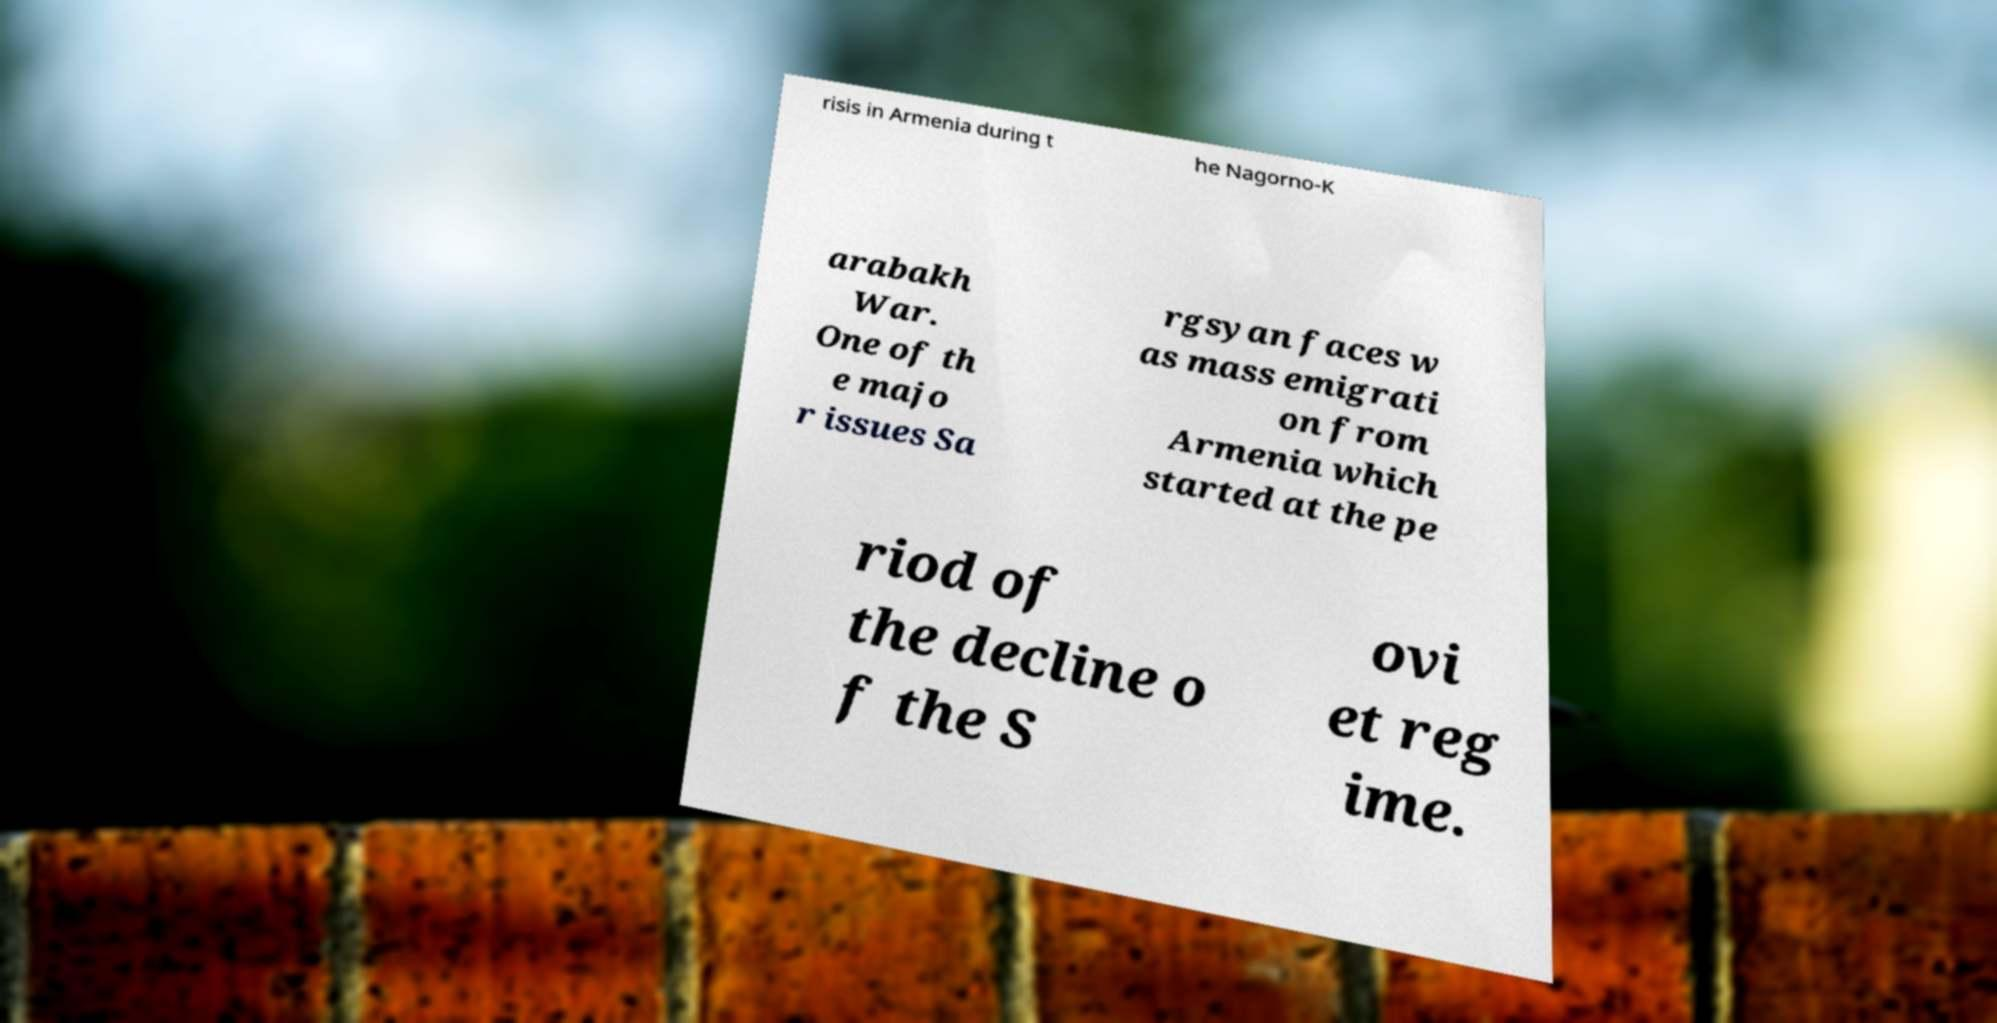For documentation purposes, I need the text within this image transcribed. Could you provide that? risis in Armenia during t he Nagorno-K arabakh War. One of th e majo r issues Sa rgsyan faces w as mass emigrati on from Armenia which started at the pe riod of the decline o f the S ovi et reg ime. 